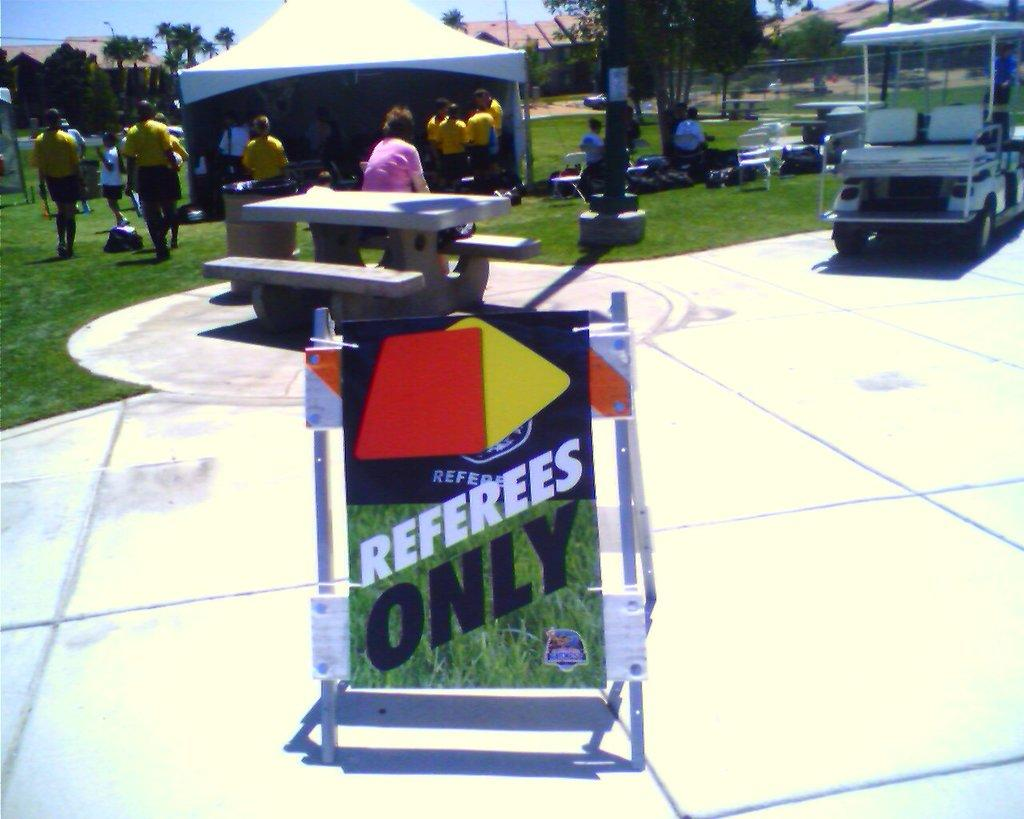<image>
Provide a brief description of the given image. Several people are gathered on a green, grass field, with a sigh in front that permits referees only. 